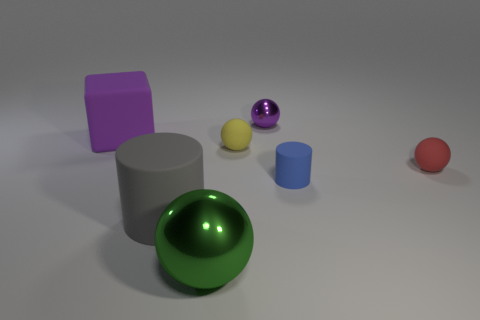The blue object that is the same shape as the large gray thing is what size?
Provide a succinct answer. Small. What is the size of the sphere that is in front of the gray rubber cylinder?
Offer a terse response. Large. Is the number of purple matte objects that are right of the red matte object greater than the number of big green metallic things?
Ensure brevity in your answer.  No. What is the shape of the blue matte object?
Provide a succinct answer. Cylinder. There is a rubber cylinder behind the large rubber cylinder; is it the same color as the metallic sphere that is to the right of the green sphere?
Give a very brief answer. No. Is the large purple thing the same shape as the big gray rubber object?
Provide a short and direct response. No. Is there anything else that has the same shape as the gray matte object?
Offer a terse response. Yes. Do the tiny thing that is in front of the red ball and the big cube have the same material?
Ensure brevity in your answer.  Yes. The tiny rubber object that is both on the left side of the small red thing and to the right of the tiny purple ball has what shape?
Offer a very short reply. Cylinder. There is a metallic thing that is to the left of the small purple metal object; are there any small blue objects that are in front of it?
Make the answer very short. No. 